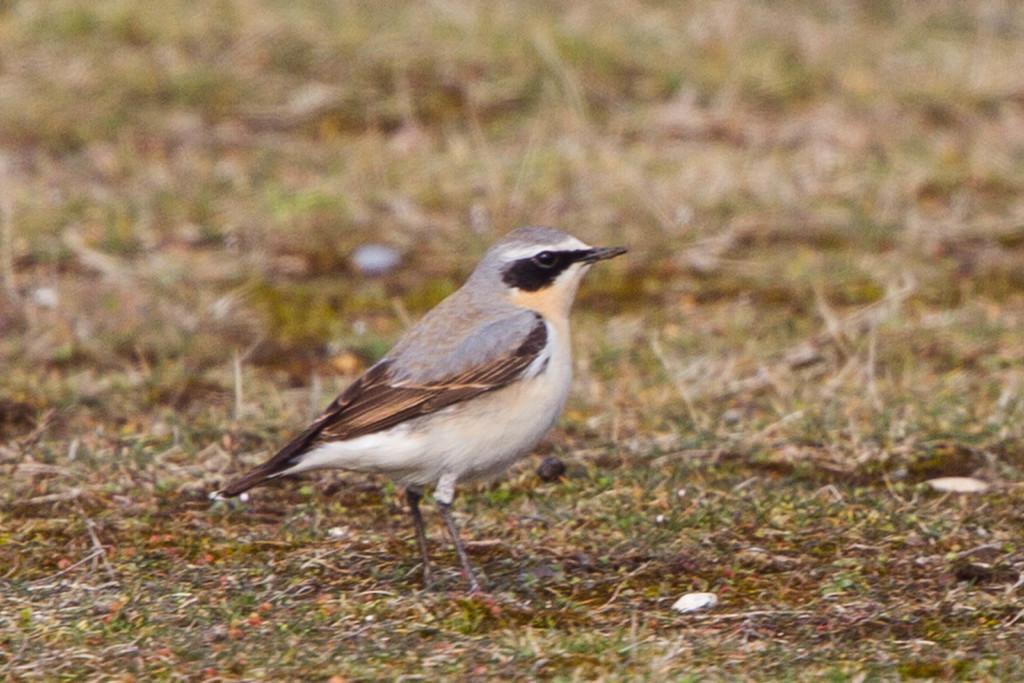How would you summarize this image in a sentence or two? In the center of the image a bird is present on the ground. In the background of the image we can see the grass. 